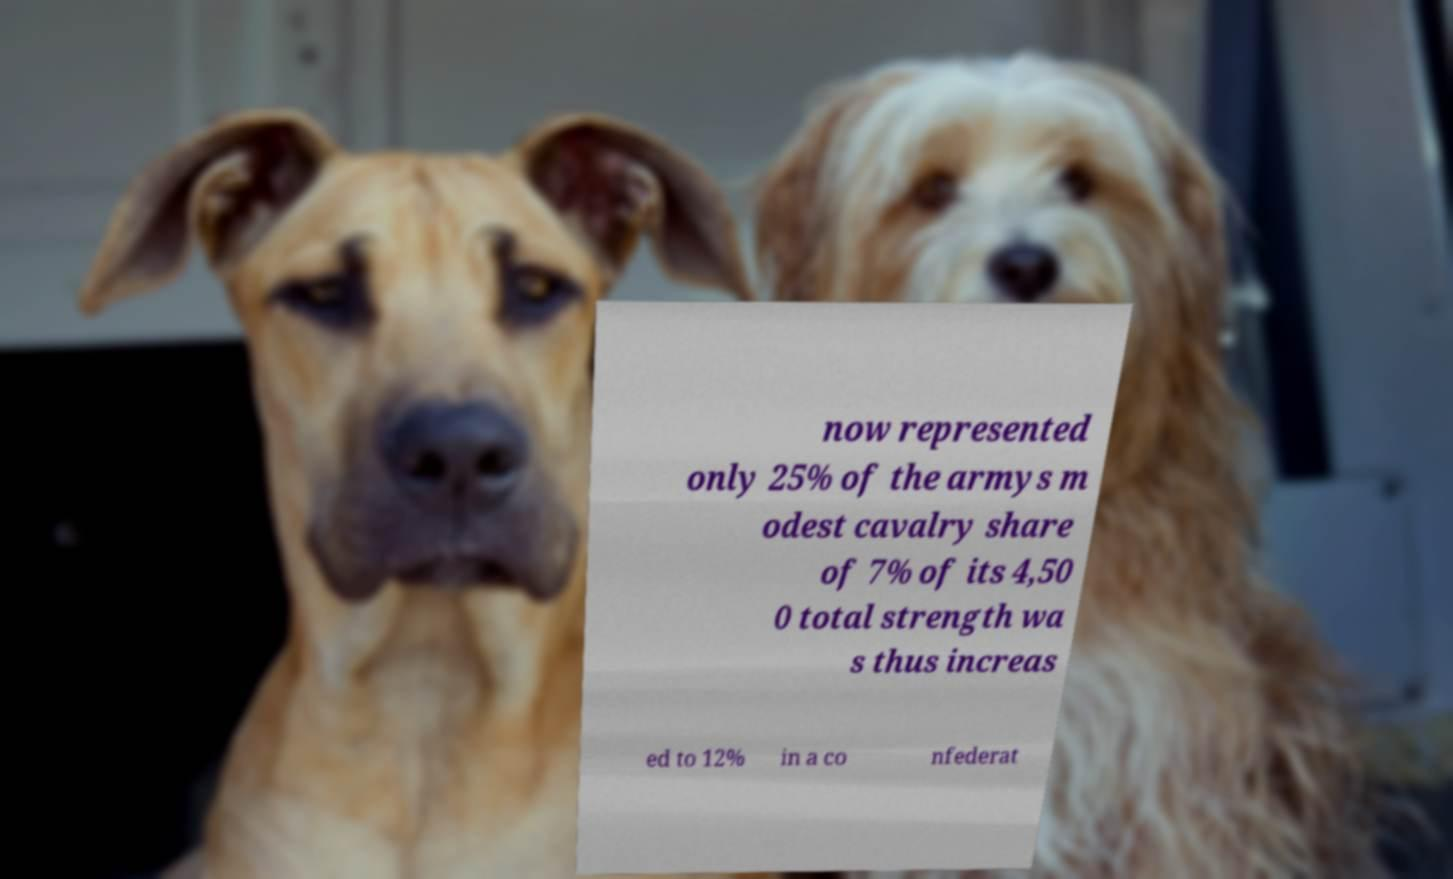Please identify and transcribe the text found in this image. now represented only 25% of the armys m odest cavalry share of 7% of its 4,50 0 total strength wa s thus increas ed to 12% in a co nfederat 